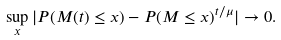<formula> <loc_0><loc_0><loc_500><loc_500>\sup _ { x } | P ( M ( t ) \leq x ) - P ( M \leq x ) ^ { t / \mu } | \to 0 .</formula> 